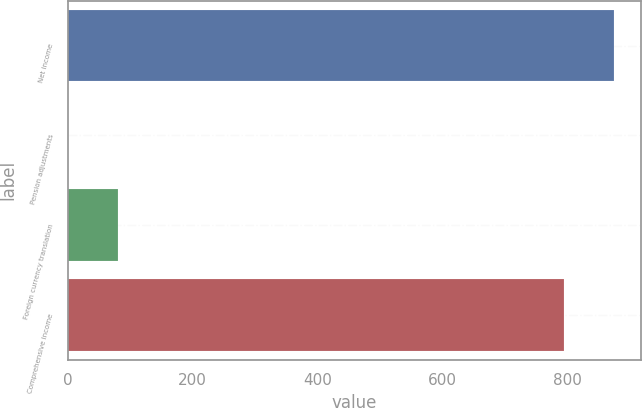<chart> <loc_0><loc_0><loc_500><loc_500><bar_chart><fcel>Net income<fcel>Pension adjustments<fcel>Foreign currency translation<fcel>Comprehensive income<nl><fcel>874.81<fcel>0.2<fcel>80.01<fcel>795<nl></chart> 